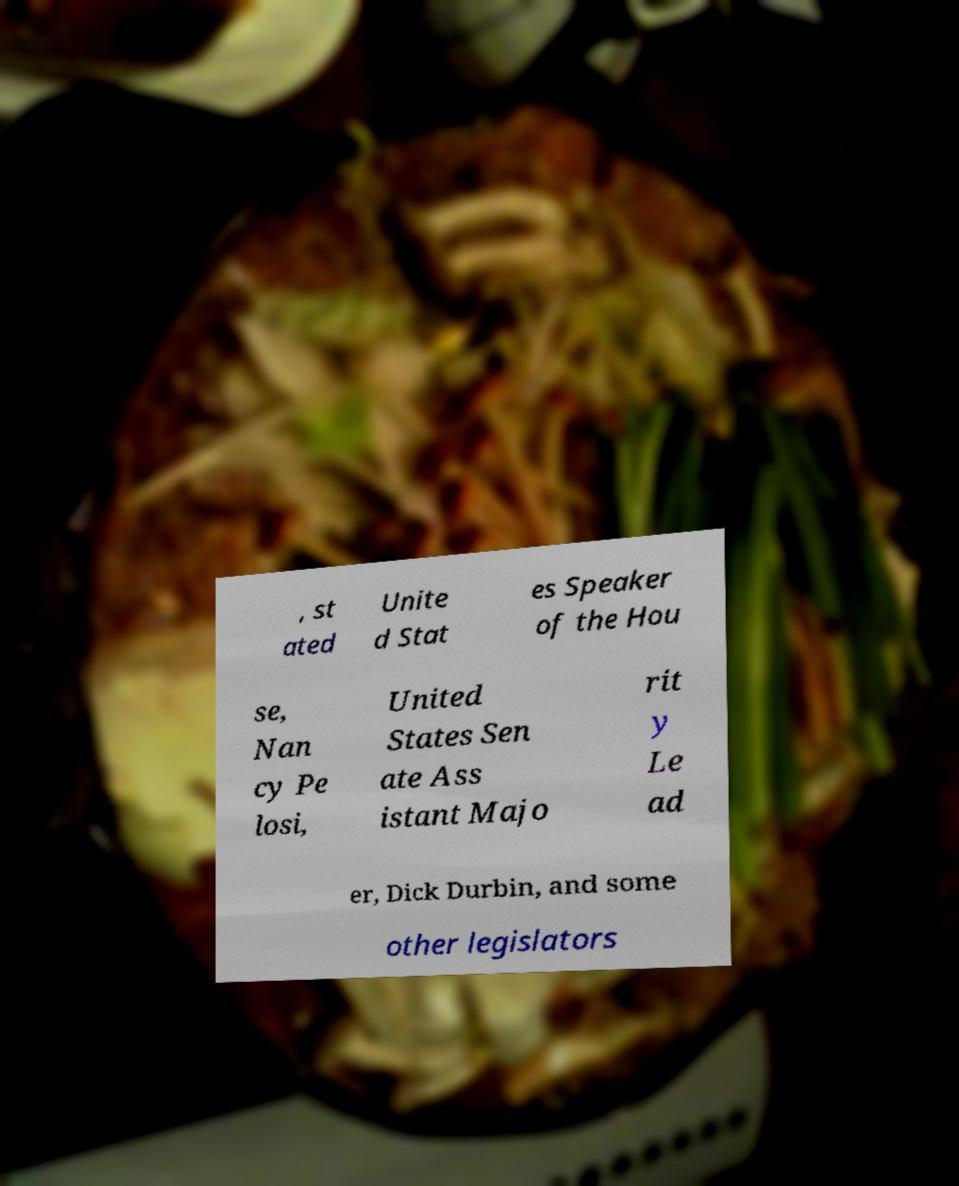Please identify and transcribe the text found in this image. , st ated Unite d Stat es Speaker of the Hou se, Nan cy Pe losi, United States Sen ate Ass istant Majo rit y Le ad er, Dick Durbin, and some other legislators 